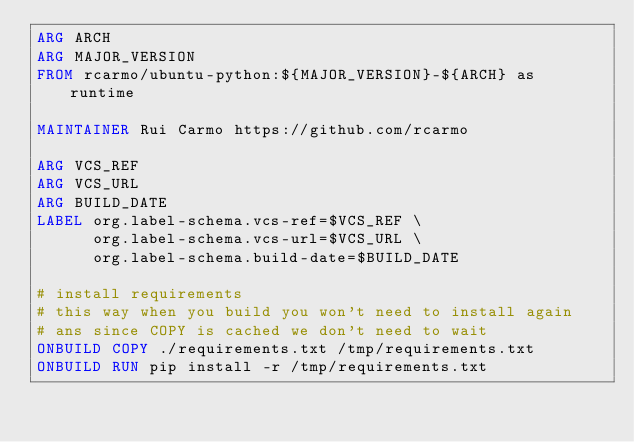Convert code to text. <code><loc_0><loc_0><loc_500><loc_500><_Dockerfile_>ARG ARCH
ARG MAJOR_VERSION
FROM rcarmo/ubuntu-python:${MAJOR_VERSION}-${ARCH} as runtime

MAINTAINER Rui Carmo https://github.com/rcarmo

ARG VCS_REF
ARG VCS_URL
ARG BUILD_DATE
LABEL org.label-schema.vcs-ref=$VCS_REF \
      org.label-schema.vcs-url=$VCS_URL \
      org.label-schema.build-date=$BUILD_DATE 

# install requirements
# this way when you build you won't need to install again
# ans since COPY is cached we don't need to wait
ONBUILD COPY ./requirements.txt /tmp/requirements.txt
ONBUILD RUN pip install -r /tmp/requirements.txt

</code> 